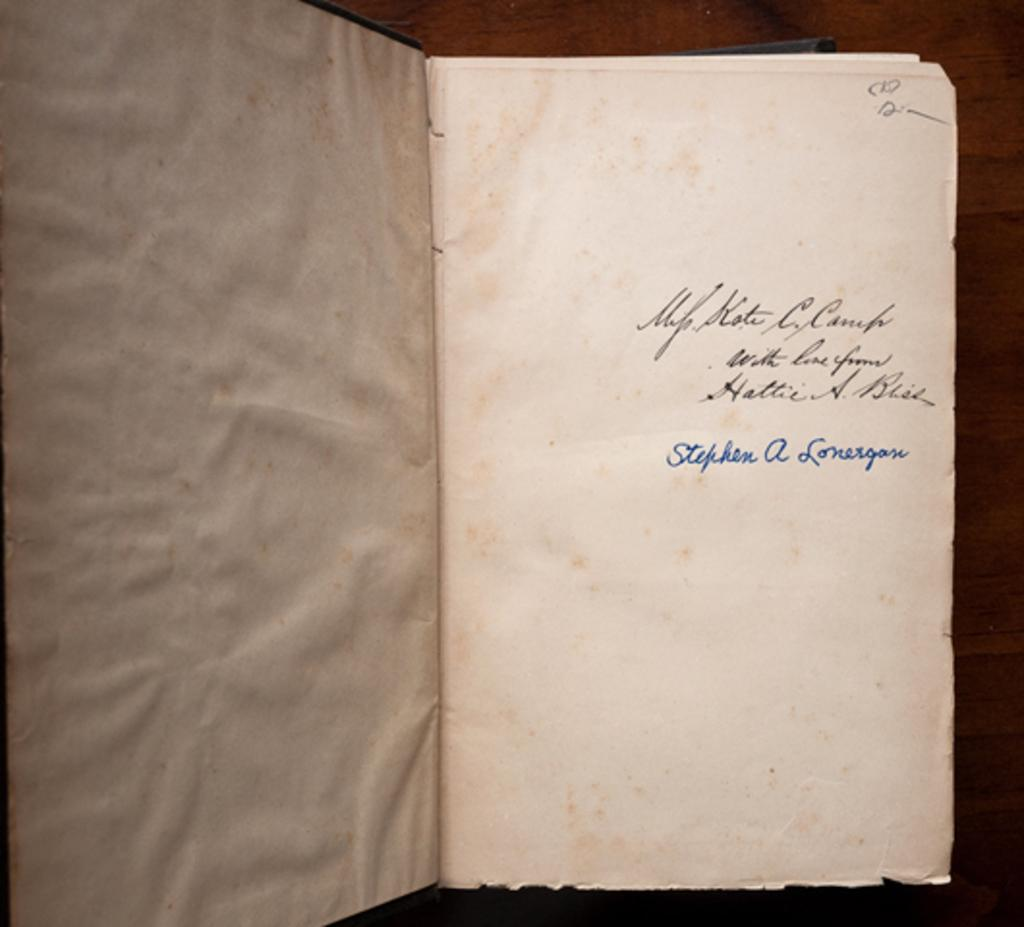Provide a one-sentence caption for the provided image. Open book showing the name Stephen A Lonergase on it. 